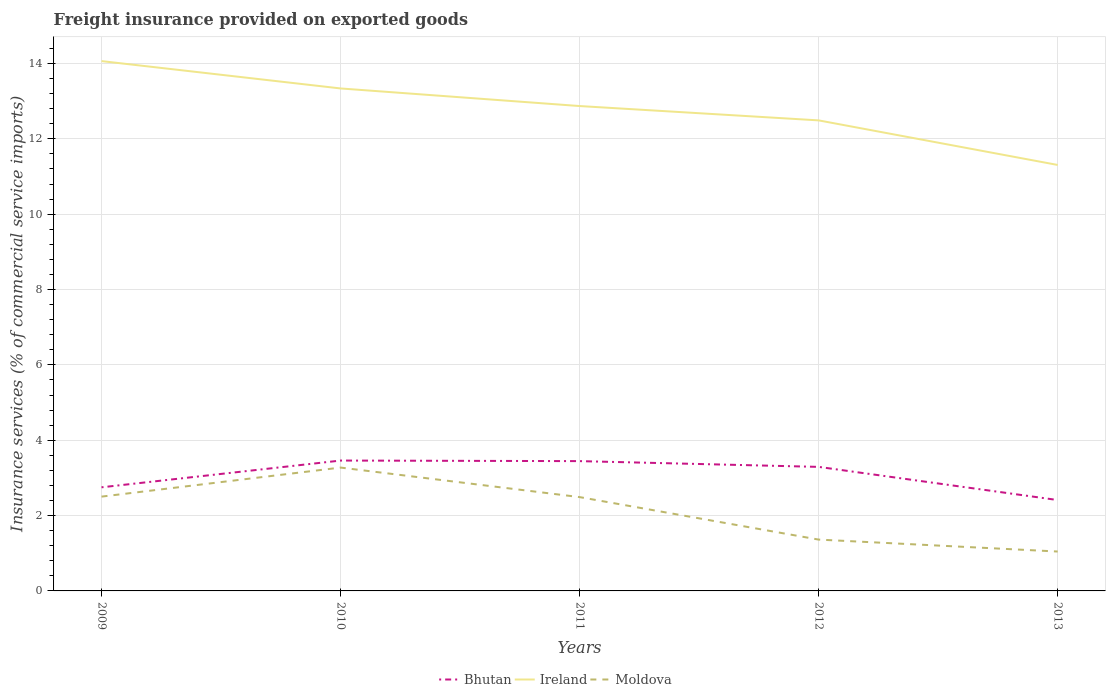How many different coloured lines are there?
Your answer should be very brief. 3. Does the line corresponding to Ireland intersect with the line corresponding to Moldova?
Provide a succinct answer. No. Is the number of lines equal to the number of legend labels?
Ensure brevity in your answer.  Yes. Across all years, what is the maximum freight insurance provided on exported goods in Bhutan?
Provide a short and direct response. 2.41. In which year was the freight insurance provided on exported goods in Bhutan maximum?
Your answer should be compact. 2013. What is the total freight insurance provided on exported goods in Moldova in the graph?
Ensure brevity in your answer.  1.44. What is the difference between the highest and the second highest freight insurance provided on exported goods in Ireland?
Make the answer very short. 2.76. What is the difference between the highest and the lowest freight insurance provided on exported goods in Moldova?
Your answer should be compact. 3. How many years are there in the graph?
Offer a terse response. 5. Where does the legend appear in the graph?
Offer a very short reply. Bottom center. How are the legend labels stacked?
Your answer should be very brief. Horizontal. What is the title of the graph?
Provide a short and direct response. Freight insurance provided on exported goods. Does "Mali" appear as one of the legend labels in the graph?
Your response must be concise. No. What is the label or title of the X-axis?
Make the answer very short. Years. What is the label or title of the Y-axis?
Provide a succinct answer. Insurance services (% of commercial service imports). What is the Insurance services (% of commercial service imports) of Bhutan in 2009?
Provide a short and direct response. 2.75. What is the Insurance services (% of commercial service imports) in Ireland in 2009?
Your answer should be compact. 14.06. What is the Insurance services (% of commercial service imports) of Moldova in 2009?
Your response must be concise. 2.5. What is the Insurance services (% of commercial service imports) of Bhutan in 2010?
Ensure brevity in your answer.  3.46. What is the Insurance services (% of commercial service imports) of Ireland in 2010?
Your response must be concise. 13.34. What is the Insurance services (% of commercial service imports) in Moldova in 2010?
Ensure brevity in your answer.  3.27. What is the Insurance services (% of commercial service imports) of Bhutan in 2011?
Offer a very short reply. 3.45. What is the Insurance services (% of commercial service imports) of Ireland in 2011?
Provide a succinct answer. 12.87. What is the Insurance services (% of commercial service imports) of Moldova in 2011?
Provide a succinct answer. 2.49. What is the Insurance services (% of commercial service imports) of Bhutan in 2012?
Give a very brief answer. 3.29. What is the Insurance services (% of commercial service imports) of Ireland in 2012?
Your response must be concise. 12.49. What is the Insurance services (% of commercial service imports) in Moldova in 2012?
Your response must be concise. 1.36. What is the Insurance services (% of commercial service imports) in Bhutan in 2013?
Your answer should be compact. 2.41. What is the Insurance services (% of commercial service imports) of Ireland in 2013?
Your response must be concise. 11.31. What is the Insurance services (% of commercial service imports) of Moldova in 2013?
Ensure brevity in your answer.  1.05. Across all years, what is the maximum Insurance services (% of commercial service imports) in Bhutan?
Make the answer very short. 3.46. Across all years, what is the maximum Insurance services (% of commercial service imports) of Ireland?
Provide a succinct answer. 14.06. Across all years, what is the maximum Insurance services (% of commercial service imports) of Moldova?
Give a very brief answer. 3.27. Across all years, what is the minimum Insurance services (% of commercial service imports) in Bhutan?
Your response must be concise. 2.41. Across all years, what is the minimum Insurance services (% of commercial service imports) of Ireland?
Your answer should be compact. 11.31. Across all years, what is the minimum Insurance services (% of commercial service imports) of Moldova?
Your answer should be very brief. 1.05. What is the total Insurance services (% of commercial service imports) in Bhutan in the graph?
Keep it short and to the point. 15.36. What is the total Insurance services (% of commercial service imports) of Ireland in the graph?
Your answer should be very brief. 64.07. What is the total Insurance services (% of commercial service imports) of Moldova in the graph?
Give a very brief answer. 10.68. What is the difference between the Insurance services (% of commercial service imports) in Bhutan in 2009 and that in 2010?
Your answer should be compact. -0.71. What is the difference between the Insurance services (% of commercial service imports) of Ireland in 2009 and that in 2010?
Provide a short and direct response. 0.73. What is the difference between the Insurance services (% of commercial service imports) in Moldova in 2009 and that in 2010?
Provide a short and direct response. -0.77. What is the difference between the Insurance services (% of commercial service imports) of Bhutan in 2009 and that in 2011?
Your answer should be very brief. -0.7. What is the difference between the Insurance services (% of commercial service imports) of Ireland in 2009 and that in 2011?
Keep it short and to the point. 1.19. What is the difference between the Insurance services (% of commercial service imports) in Moldova in 2009 and that in 2011?
Your answer should be very brief. 0.01. What is the difference between the Insurance services (% of commercial service imports) of Bhutan in 2009 and that in 2012?
Keep it short and to the point. -0.54. What is the difference between the Insurance services (% of commercial service imports) of Ireland in 2009 and that in 2012?
Your answer should be compact. 1.57. What is the difference between the Insurance services (% of commercial service imports) of Moldova in 2009 and that in 2012?
Your response must be concise. 1.14. What is the difference between the Insurance services (% of commercial service imports) of Bhutan in 2009 and that in 2013?
Offer a terse response. 0.34. What is the difference between the Insurance services (% of commercial service imports) of Ireland in 2009 and that in 2013?
Your response must be concise. 2.76. What is the difference between the Insurance services (% of commercial service imports) in Moldova in 2009 and that in 2013?
Your answer should be compact. 1.46. What is the difference between the Insurance services (% of commercial service imports) of Bhutan in 2010 and that in 2011?
Ensure brevity in your answer.  0.02. What is the difference between the Insurance services (% of commercial service imports) in Ireland in 2010 and that in 2011?
Offer a very short reply. 0.47. What is the difference between the Insurance services (% of commercial service imports) in Moldova in 2010 and that in 2011?
Provide a succinct answer. 0.78. What is the difference between the Insurance services (% of commercial service imports) of Bhutan in 2010 and that in 2012?
Your answer should be compact. 0.17. What is the difference between the Insurance services (% of commercial service imports) of Ireland in 2010 and that in 2012?
Offer a very short reply. 0.85. What is the difference between the Insurance services (% of commercial service imports) in Moldova in 2010 and that in 2012?
Provide a succinct answer. 1.91. What is the difference between the Insurance services (% of commercial service imports) in Bhutan in 2010 and that in 2013?
Provide a succinct answer. 1.05. What is the difference between the Insurance services (% of commercial service imports) of Ireland in 2010 and that in 2013?
Provide a short and direct response. 2.03. What is the difference between the Insurance services (% of commercial service imports) in Moldova in 2010 and that in 2013?
Keep it short and to the point. 2.23. What is the difference between the Insurance services (% of commercial service imports) in Bhutan in 2011 and that in 2012?
Offer a very short reply. 0.15. What is the difference between the Insurance services (% of commercial service imports) of Ireland in 2011 and that in 2012?
Your answer should be compact. 0.38. What is the difference between the Insurance services (% of commercial service imports) in Moldova in 2011 and that in 2012?
Provide a succinct answer. 1.13. What is the difference between the Insurance services (% of commercial service imports) in Bhutan in 2011 and that in 2013?
Your answer should be compact. 1.03. What is the difference between the Insurance services (% of commercial service imports) in Ireland in 2011 and that in 2013?
Ensure brevity in your answer.  1.56. What is the difference between the Insurance services (% of commercial service imports) of Moldova in 2011 and that in 2013?
Provide a short and direct response. 1.44. What is the difference between the Insurance services (% of commercial service imports) of Bhutan in 2012 and that in 2013?
Provide a short and direct response. 0.88. What is the difference between the Insurance services (% of commercial service imports) in Ireland in 2012 and that in 2013?
Your answer should be compact. 1.18. What is the difference between the Insurance services (% of commercial service imports) in Moldova in 2012 and that in 2013?
Provide a succinct answer. 0.32. What is the difference between the Insurance services (% of commercial service imports) in Bhutan in 2009 and the Insurance services (% of commercial service imports) in Ireland in 2010?
Your answer should be compact. -10.59. What is the difference between the Insurance services (% of commercial service imports) of Bhutan in 2009 and the Insurance services (% of commercial service imports) of Moldova in 2010?
Provide a short and direct response. -0.52. What is the difference between the Insurance services (% of commercial service imports) in Ireland in 2009 and the Insurance services (% of commercial service imports) in Moldova in 2010?
Make the answer very short. 10.79. What is the difference between the Insurance services (% of commercial service imports) of Bhutan in 2009 and the Insurance services (% of commercial service imports) of Ireland in 2011?
Give a very brief answer. -10.12. What is the difference between the Insurance services (% of commercial service imports) of Bhutan in 2009 and the Insurance services (% of commercial service imports) of Moldova in 2011?
Ensure brevity in your answer.  0.26. What is the difference between the Insurance services (% of commercial service imports) in Ireland in 2009 and the Insurance services (% of commercial service imports) in Moldova in 2011?
Your answer should be compact. 11.57. What is the difference between the Insurance services (% of commercial service imports) of Bhutan in 2009 and the Insurance services (% of commercial service imports) of Ireland in 2012?
Ensure brevity in your answer.  -9.74. What is the difference between the Insurance services (% of commercial service imports) of Bhutan in 2009 and the Insurance services (% of commercial service imports) of Moldova in 2012?
Provide a succinct answer. 1.39. What is the difference between the Insurance services (% of commercial service imports) of Ireland in 2009 and the Insurance services (% of commercial service imports) of Moldova in 2012?
Provide a succinct answer. 12.7. What is the difference between the Insurance services (% of commercial service imports) of Bhutan in 2009 and the Insurance services (% of commercial service imports) of Ireland in 2013?
Provide a succinct answer. -8.56. What is the difference between the Insurance services (% of commercial service imports) of Bhutan in 2009 and the Insurance services (% of commercial service imports) of Moldova in 2013?
Your answer should be compact. 1.7. What is the difference between the Insurance services (% of commercial service imports) of Ireland in 2009 and the Insurance services (% of commercial service imports) of Moldova in 2013?
Provide a short and direct response. 13.02. What is the difference between the Insurance services (% of commercial service imports) of Bhutan in 2010 and the Insurance services (% of commercial service imports) of Ireland in 2011?
Your response must be concise. -9.41. What is the difference between the Insurance services (% of commercial service imports) of Bhutan in 2010 and the Insurance services (% of commercial service imports) of Moldova in 2011?
Keep it short and to the point. 0.97. What is the difference between the Insurance services (% of commercial service imports) in Ireland in 2010 and the Insurance services (% of commercial service imports) in Moldova in 2011?
Keep it short and to the point. 10.85. What is the difference between the Insurance services (% of commercial service imports) of Bhutan in 2010 and the Insurance services (% of commercial service imports) of Ireland in 2012?
Offer a very short reply. -9.03. What is the difference between the Insurance services (% of commercial service imports) in Bhutan in 2010 and the Insurance services (% of commercial service imports) in Moldova in 2012?
Keep it short and to the point. 2.1. What is the difference between the Insurance services (% of commercial service imports) in Ireland in 2010 and the Insurance services (% of commercial service imports) in Moldova in 2012?
Your answer should be very brief. 11.97. What is the difference between the Insurance services (% of commercial service imports) of Bhutan in 2010 and the Insurance services (% of commercial service imports) of Ireland in 2013?
Your response must be concise. -7.85. What is the difference between the Insurance services (% of commercial service imports) in Bhutan in 2010 and the Insurance services (% of commercial service imports) in Moldova in 2013?
Offer a very short reply. 2.41. What is the difference between the Insurance services (% of commercial service imports) in Ireland in 2010 and the Insurance services (% of commercial service imports) in Moldova in 2013?
Offer a very short reply. 12.29. What is the difference between the Insurance services (% of commercial service imports) in Bhutan in 2011 and the Insurance services (% of commercial service imports) in Ireland in 2012?
Make the answer very short. -9.04. What is the difference between the Insurance services (% of commercial service imports) in Bhutan in 2011 and the Insurance services (% of commercial service imports) in Moldova in 2012?
Provide a short and direct response. 2.08. What is the difference between the Insurance services (% of commercial service imports) of Ireland in 2011 and the Insurance services (% of commercial service imports) of Moldova in 2012?
Keep it short and to the point. 11.51. What is the difference between the Insurance services (% of commercial service imports) in Bhutan in 2011 and the Insurance services (% of commercial service imports) in Ireland in 2013?
Give a very brief answer. -7.86. What is the difference between the Insurance services (% of commercial service imports) of Bhutan in 2011 and the Insurance services (% of commercial service imports) of Moldova in 2013?
Your answer should be very brief. 2.4. What is the difference between the Insurance services (% of commercial service imports) of Ireland in 2011 and the Insurance services (% of commercial service imports) of Moldova in 2013?
Offer a terse response. 11.82. What is the difference between the Insurance services (% of commercial service imports) in Bhutan in 2012 and the Insurance services (% of commercial service imports) in Ireland in 2013?
Your response must be concise. -8.01. What is the difference between the Insurance services (% of commercial service imports) in Bhutan in 2012 and the Insurance services (% of commercial service imports) in Moldova in 2013?
Offer a very short reply. 2.25. What is the difference between the Insurance services (% of commercial service imports) in Ireland in 2012 and the Insurance services (% of commercial service imports) in Moldova in 2013?
Provide a succinct answer. 11.44. What is the average Insurance services (% of commercial service imports) in Bhutan per year?
Provide a succinct answer. 3.07. What is the average Insurance services (% of commercial service imports) in Ireland per year?
Your response must be concise. 12.81. What is the average Insurance services (% of commercial service imports) of Moldova per year?
Your answer should be very brief. 2.14. In the year 2009, what is the difference between the Insurance services (% of commercial service imports) of Bhutan and Insurance services (% of commercial service imports) of Ireland?
Provide a succinct answer. -11.31. In the year 2009, what is the difference between the Insurance services (% of commercial service imports) in Bhutan and Insurance services (% of commercial service imports) in Moldova?
Your answer should be very brief. 0.25. In the year 2009, what is the difference between the Insurance services (% of commercial service imports) in Ireland and Insurance services (% of commercial service imports) in Moldova?
Provide a succinct answer. 11.56. In the year 2010, what is the difference between the Insurance services (% of commercial service imports) of Bhutan and Insurance services (% of commercial service imports) of Ireland?
Provide a short and direct response. -9.88. In the year 2010, what is the difference between the Insurance services (% of commercial service imports) in Bhutan and Insurance services (% of commercial service imports) in Moldova?
Provide a short and direct response. 0.19. In the year 2010, what is the difference between the Insurance services (% of commercial service imports) of Ireland and Insurance services (% of commercial service imports) of Moldova?
Ensure brevity in your answer.  10.06. In the year 2011, what is the difference between the Insurance services (% of commercial service imports) in Bhutan and Insurance services (% of commercial service imports) in Ireland?
Provide a succinct answer. -9.42. In the year 2011, what is the difference between the Insurance services (% of commercial service imports) of Bhutan and Insurance services (% of commercial service imports) of Moldova?
Provide a succinct answer. 0.96. In the year 2011, what is the difference between the Insurance services (% of commercial service imports) of Ireland and Insurance services (% of commercial service imports) of Moldova?
Make the answer very short. 10.38. In the year 2012, what is the difference between the Insurance services (% of commercial service imports) of Bhutan and Insurance services (% of commercial service imports) of Ireland?
Your answer should be compact. -9.2. In the year 2012, what is the difference between the Insurance services (% of commercial service imports) of Bhutan and Insurance services (% of commercial service imports) of Moldova?
Make the answer very short. 1.93. In the year 2012, what is the difference between the Insurance services (% of commercial service imports) in Ireland and Insurance services (% of commercial service imports) in Moldova?
Keep it short and to the point. 11.13. In the year 2013, what is the difference between the Insurance services (% of commercial service imports) of Bhutan and Insurance services (% of commercial service imports) of Ireland?
Provide a succinct answer. -8.89. In the year 2013, what is the difference between the Insurance services (% of commercial service imports) in Bhutan and Insurance services (% of commercial service imports) in Moldova?
Your answer should be very brief. 1.37. In the year 2013, what is the difference between the Insurance services (% of commercial service imports) in Ireland and Insurance services (% of commercial service imports) in Moldova?
Offer a very short reply. 10.26. What is the ratio of the Insurance services (% of commercial service imports) of Bhutan in 2009 to that in 2010?
Offer a terse response. 0.79. What is the ratio of the Insurance services (% of commercial service imports) of Ireland in 2009 to that in 2010?
Provide a succinct answer. 1.05. What is the ratio of the Insurance services (% of commercial service imports) of Moldova in 2009 to that in 2010?
Ensure brevity in your answer.  0.76. What is the ratio of the Insurance services (% of commercial service imports) of Bhutan in 2009 to that in 2011?
Your answer should be compact. 0.8. What is the ratio of the Insurance services (% of commercial service imports) of Ireland in 2009 to that in 2011?
Your answer should be very brief. 1.09. What is the ratio of the Insurance services (% of commercial service imports) in Bhutan in 2009 to that in 2012?
Ensure brevity in your answer.  0.84. What is the ratio of the Insurance services (% of commercial service imports) in Ireland in 2009 to that in 2012?
Your answer should be compact. 1.13. What is the ratio of the Insurance services (% of commercial service imports) in Moldova in 2009 to that in 2012?
Offer a very short reply. 1.84. What is the ratio of the Insurance services (% of commercial service imports) in Bhutan in 2009 to that in 2013?
Ensure brevity in your answer.  1.14. What is the ratio of the Insurance services (% of commercial service imports) of Ireland in 2009 to that in 2013?
Your answer should be very brief. 1.24. What is the ratio of the Insurance services (% of commercial service imports) of Moldova in 2009 to that in 2013?
Ensure brevity in your answer.  2.39. What is the ratio of the Insurance services (% of commercial service imports) in Bhutan in 2010 to that in 2011?
Keep it short and to the point. 1. What is the ratio of the Insurance services (% of commercial service imports) of Ireland in 2010 to that in 2011?
Your answer should be compact. 1.04. What is the ratio of the Insurance services (% of commercial service imports) in Moldova in 2010 to that in 2011?
Your answer should be compact. 1.31. What is the ratio of the Insurance services (% of commercial service imports) of Bhutan in 2010 to that in 2012?
Ensure brevity in your answer.  1.05. What is the ratio of the Insurance services (% of commercial service imports) in Ireland in 2010 to that in 2012?
Provide a short and direct response. 1.07. What is the ratio of the Insurance services (% of commercial service imports) of Moldova in 2010 to that in 2012?
Your answer should be very brief. 2.4. What is the ratio of the Insurance services (% of commercial service imports) of Bhutan in 2010 to that in 2013?
Keep it short and to the point. 1.43. What is the ratio of the Insurance services (% of commercial service imports) of Ireland in 2010 to that in 2013?
Ensure brevity in your answer.  1.18. What is the ratio of the Insurance services (% of commercial service imports) in Moldova in 2010 to that in 2013?
Your response must be concise. 3.13. What is the ratio of the Insurance services (% of commercial service imports) in Bhutan in 2011 to that in 2012?
Offer a very short reply. 1.05. What is the ratio of the Insurance services (% of commercial service imports) of Ireland in 2011 to that in 2012?
Ensure brevity in your answer.  1.03. What is the ratio of the Insurance services (% of commercial service imports) in Moldova in 2011 to that in 2012?
Offer a very short reply. 1.83. What is the ratio of the Insurance services (% of commercial service imports) of Bhutan in 2011 to that in 2013?
Make the answer very short. 1.43. What is the ratio of the Insurance services (% of commercial service imports) in Ireland in 2011 to that in 2013?
Your response must be concise. 1.14. What is the ratio of the Insurance services (% of commercial service imports) in Moldova in 2011 to that in 2013?
Offer a very short reply. 2.38. What is the ratio of the Insurance services (% of commercial service imports) of Bhutan in 2012 to that in 2013?
Your answer should be very brief. 1.36. What is the ratio of the Insurance services (% of commercial service imports) in Ireland in 2012 to that in 2013?
Ensure brevity in your answer.  1.1. What is the ratio of the Insurance services (% of commercial service imports) of Moldova in 2012 to that in 2013?
Keep it short and to the point. 1.3. What is the difference between the highest and the second highest Insurance services (% of commercial service imports) of Bhutan?
Provide a succinct answer. 0.02. What is the difference between the highest and the second highest Insurance services (% of commercial service imports) of Ireland?
Make the answer very short. 0.73. What is the difference between the highest and the second highest Insurance services (% of commercial service imports) in Moldova?
Offer a very short reply. 0.77. What is the difference between the highest and the lowest Insurance services (% of commercial service imports) in Bhutan?
Offer a very short reply. 1.05. What is the difference between the highest and the lowest Insurance services (% of commercial service imports) in Ireland?
Ensure brevity in your answer.  2.76. What is the difference between the highest and the lowest Insurance services (% of commercial service imports) of Moldova?
Give a very brief answer. 2.23. 